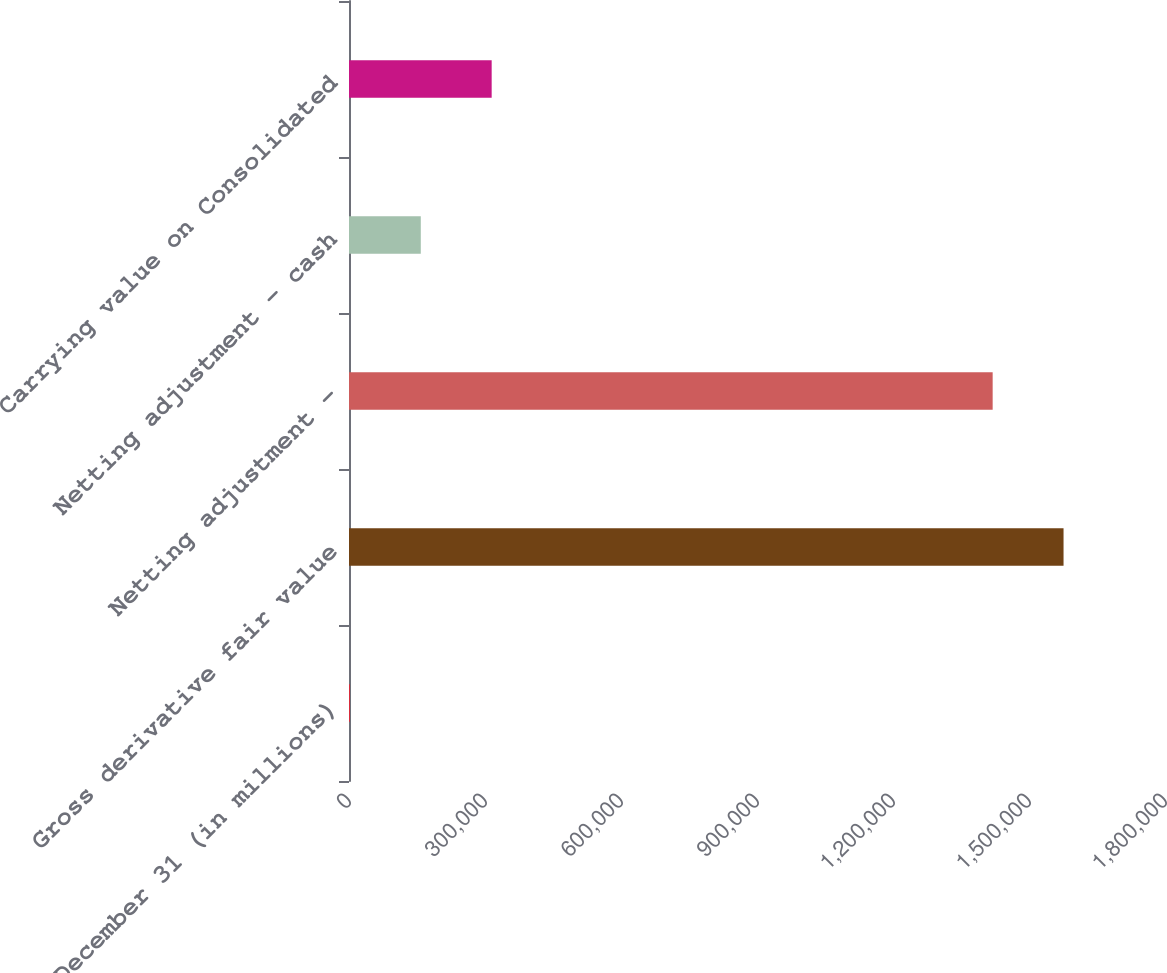Convert chart to OTSL. <chart><loc_0><loc_0><loc_500><loc_500><bar_chart><fcel>December 31 (in millions)<fcel>Gross derivative fair value<fcel>Netting adjustment -<fcel>Netting adjustment - cash<fcel>Carrying value on Consolidated<nl><fcel>2009<fcel>1.57619e+06<fcel>1.41984e+06<fcel>158360<fcel>314711<nl></chart> 